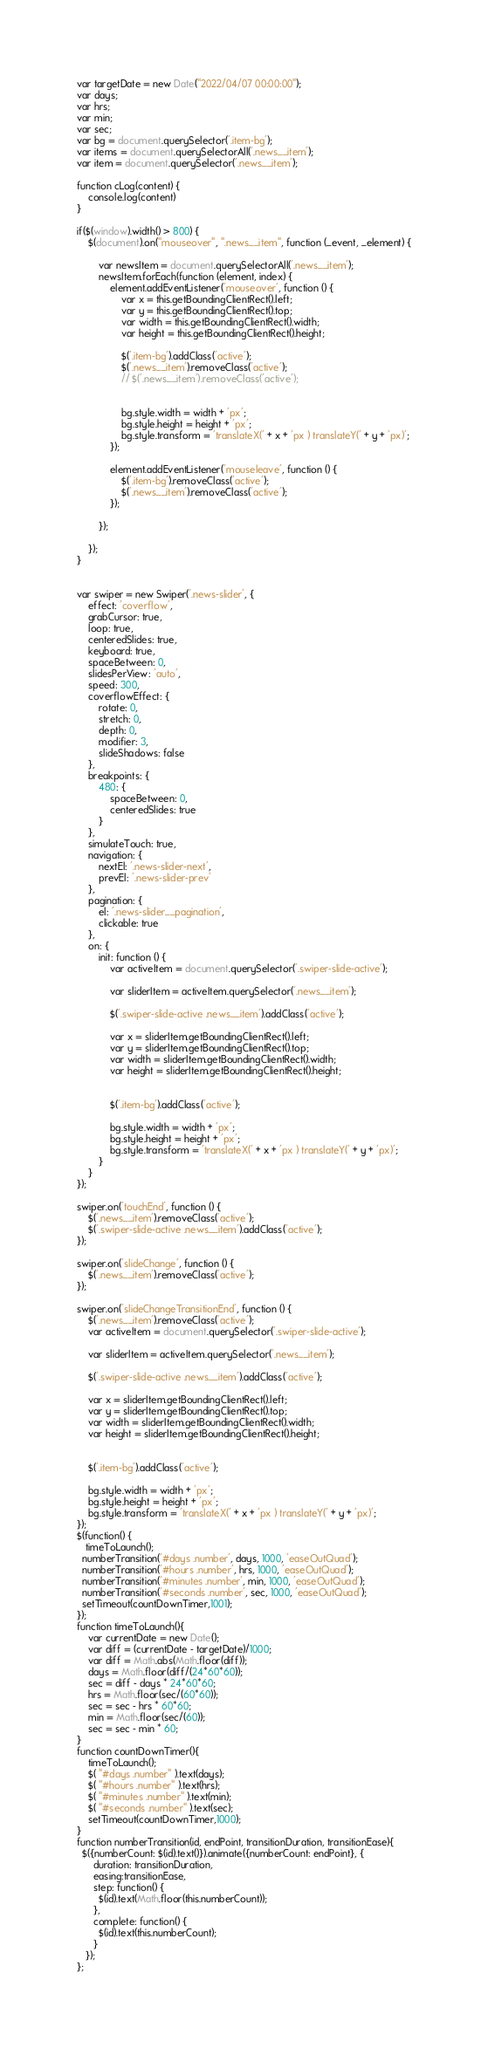<code> <loc_0><loc_0><loc_500><loc_500><_JavaScript_>var targetDate = new Date("2022/04/07 00:00:00");   
var days;
var hrs;
var min;
var sec;
var bg = document.querySelector('.item-bg');
var items = document.querySelectorAll('.news__item');
var item = document.querySelector('.news__item');

function cLog(content) {
    console.log(content)
}

if($(window).width() > 800) {
    $(document).on("mouseover", ".news__item", function (_event, _element) {

        var newsItem = document.querySelectorAll('.news__item');
        newsItem.forEach(function (element, index) {
            element.addEventListener('mouseover', function () {
                var x = this.getBoundingClientRect().left;
                var y = this.getBoundingClientRect().top;
                var width = this.getBoundingClientRect().width;
                var height = this.getBoundingClientRect().height;

                $('.item-bg').addClass('active');
                $('.news__item').removeClass('active');
                // $('.news__item').removeClass('active');


                bg.style.width = width + 'px';
                bg.style.height = height + 'px';
                bg.style.transform = 'translateX(' + x + 'px ) translateY(' + y + 'px)';
            });

            element.addEventListener('mouseleave', function () {
                $('.item-bg').removeClass('active');
                $('.news__item').removeClass('active');
            });

        });

    });
}


var swiper = new Swiper('.news-slider', {
    effect: 'coverflow',
    grabCursor: true,
    loop: true,
    centeredSlides: true,
    keyboard: true,
    spaceBetween: 0,
    slidesPerView: 'auto',
    speed: 300,
    coverflowEffect: {
        rotate: 0,
        stretch: 0,
        depth: 0,
        modifier: 3,
        slideShadows: false
    },
    breakpoints: {
        480: {
            spaceBetween: 0,
            centeredSlides: true
        }
    },
    simulateTouch: true,
    navigation: {
        nextEl: '.news-slider-next',
        prevEl: '.news-slider-prev'
    },
    pagination: {
        el: '.news-slider__pagination',
        clickable: true
    },
    on: {
        init: function () {
            var activeItem = document.querySelector('.swiper-slide-active');

            var sliderItem = activeItem.querySelector('.news__item');

            $('.swiper-slide-active .news__item').addClass('active');

            var x = sliderItem.getBoundingClientRect().left;
            var y = sliderItem.getBoundingClientRect().top;
            var width = sliderItem.getBoundingClientRect().width;
            var height = sliderItem.getBoundingClientRect().height;


            $('.item-bg').addClass('active');

            bg.style.width = width + 'px';
            bg.style.height = height + 'px';
            bg.style.transform = 'translateX(' + x + 'px ) translateY(' + y + 'px)';
        }
    }
});

swiper.on('touchEnd', function () {
    $('.news__item').removeClass('active');
    $('.swiper-slide-active .news__item').addClass('active');
});

swiper.on('slideChange', function () {
    $('.news__item').removeClass('active');
});

swiper.on('slideChangeTransitionEnd', function () {
    $('.news__item').removeClass('active');
    var activeItem = document.querySelector('.swiper-slide-active');

    var sliderItem = activeItem.querySelector('.news__item');

    $('.swiper-slide-active .news__item').addClass('active');

    var x = sliderItem.getBoundingClientRect().left;
    var y = sliderItem.getBoundingClientRect().top;
    var width = sliderItem.getBoundingClientRect().width;
    var height = sliderItem.getBoundingClientRect().height;


    $('.item-bg').addClass('active');

    bg.style.width = width + 'px';
    bg.style.height = height + 'px';
    bg.style.transform = 'translateX(' + x + 'px ) translateY(' + y + 'px)';
});
$(function() {
   timeToLaunch(); 
  numberTransition('#days .number', days, 1000, 'easeOutQuad');
  numberTransition('#hours .number', hrs, 1000, 'easeOutQuad');
  numberTransition('#minutes .number', min, 1000, 'easeOutQuad');
  numberTransition('#seconds .number', sec, 1000, 'easeOutQuad');
  setTimeout(countDownTimer,1001);
});
function timeToLaunch(){
    var currentDate = new Date();
    var diff = (currentDate - targetDate)/1000;
    var diff = Math.abs(Math.floor(diff));  
    days = Math.floor(diff/(24*60*60));
    sec = diff - days * 24*60*60;
    hrs = Math.floor(sec/(60*60));
    sec = sec - hrs * 60*60;
    min = Math.floor(sec/(60));
    sec = sec - min * 60;
}
function countDownTimer(){ 
    timeToLaunch();
    $( "#days .number" ).text(days);
    $( "#hours .number" ).text(hrs);
    $( "#minutes .number" ).text(min);
    $( "#seconds .number" ).text(sec);
    setTimeout(countDownTimer,1000);
}
function numberTransition(id, endPoint, transitionDuration, transitionEase){
  $({numberCount: $(id).text()}).animate({numberCount: endPoint}, {
      duration: transitionDuration,
      easing:transitionEase,
      step: function() {
        $(id).text(Math.floor(this.numberCount));
      },
      complete: function() {
        $(id).text(this.numberCount);
      }
   }); 
};
</code> 